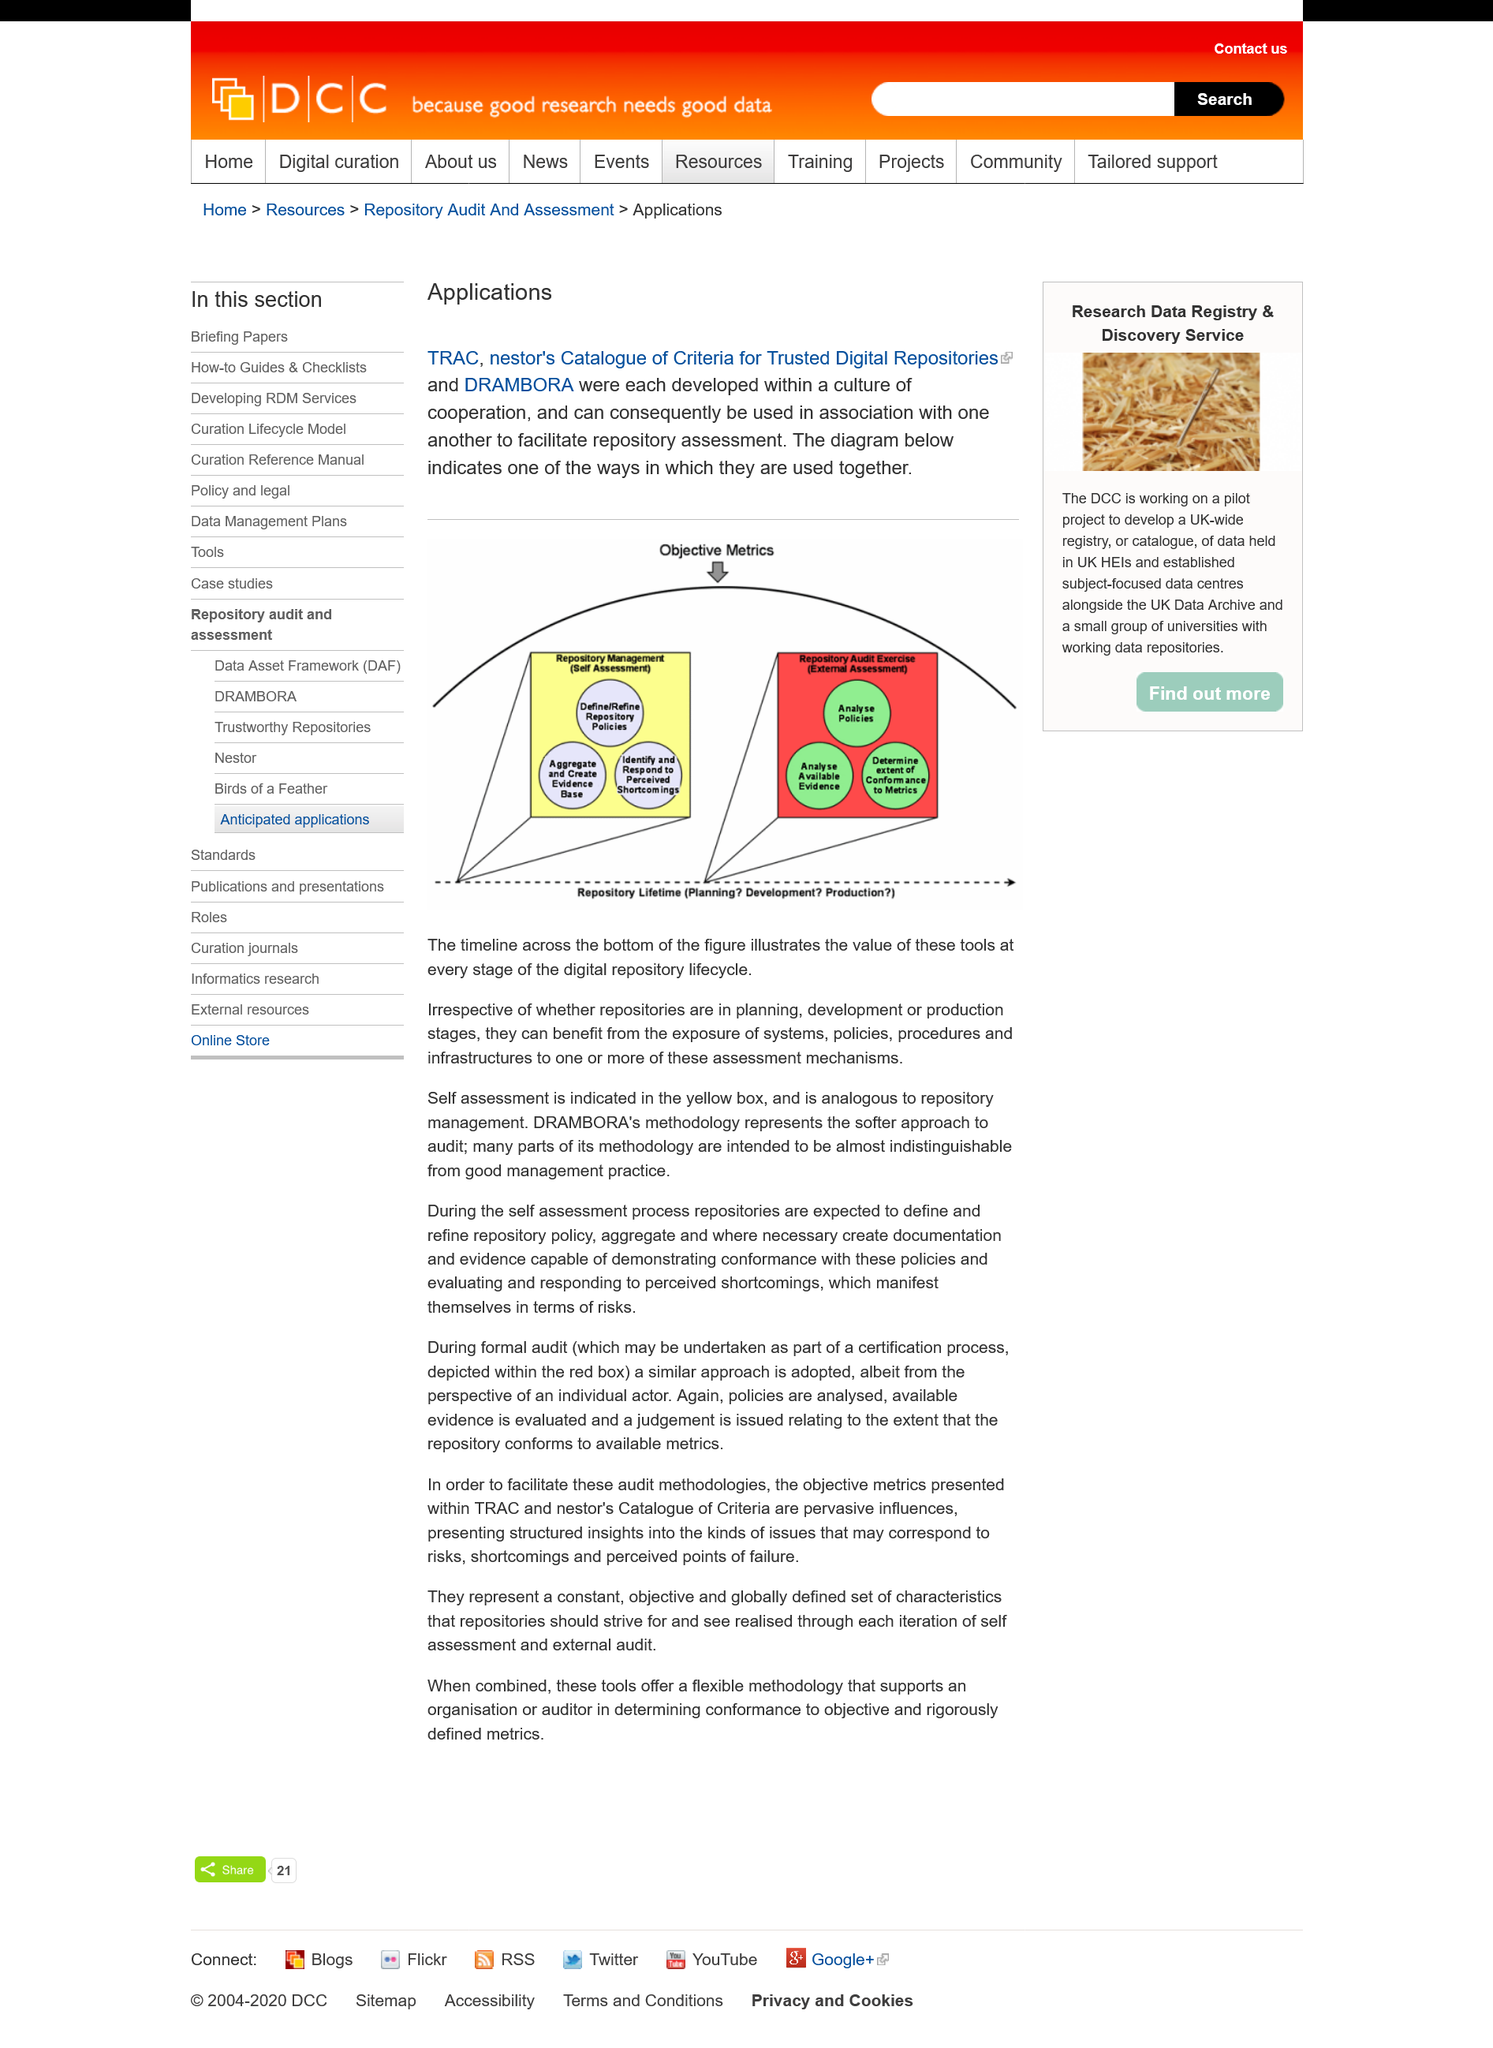Indicate a few pertinent items in this graphic. The timeline across the bottom of the figure illustrates the value of these tools at every stage of the digital repository development process, from planning and design to implementation and maintenance. The diagram below illustrates one of the ways in which the two items are used together. TRAC, nestor's Catalogue of Criteria for Trusted Digital Repositories, and DRAMBORA were developed within a culture of cooperation and collaboration between various stakeholders in the digital preservation community. 